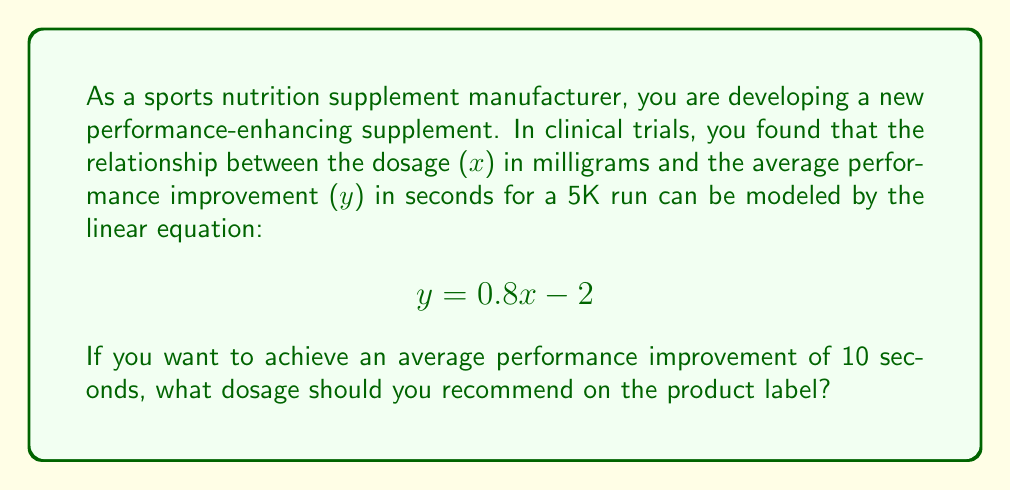Could you help me with this problem? To solve this problem, we need to use the given linear equation and find the value of x (dosage) when y (performance improvement) is 10 seconds. Let's follow these steps:

1. Start with the given equation:
   $$ y = 0.8x - 2 $$

2. Substitute y with 10 (the desired performance improvement):
   $$ 10 = 0.8x - 2 $$

3. Add 2 to both sides of the equation to isolate the term with x:
   $$ 12 = 0.8x $$

4. Divide both sides by 0.8 to solve for x:
   $$ x = \frac{12}{0.8} = 15 $$

Therefore, to achieve an average performance improvement of 10 seconds, the recommended dosage should be 15 milligrams.

It's important to note that as a supplement manufacturer, you should always consider safety guidelines and regulatory requirements when determining final dosage recommendations.
Answer: 15 milligrams 